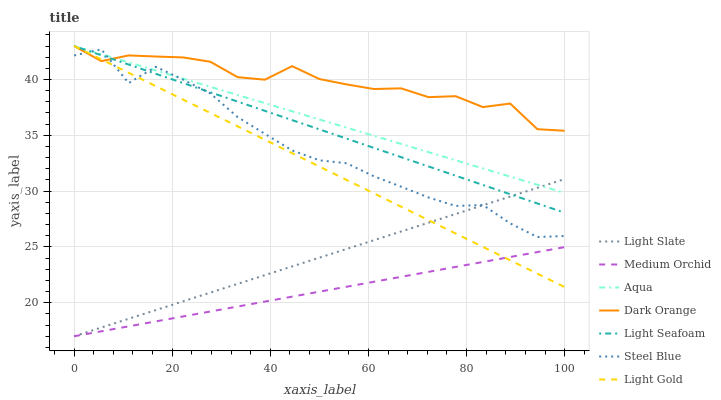Does Light Slate have the minimum area under the curve?
Answer yes or no. No. Does Light Slate have the maximum area under the curve?
Answer yes or no. No. Is Medium Orchid the smoothest?
Answer yes or no. No. Is Medium Orchid the roughest?
Answer yes or no. No. Does Aqua have the lowest value?
Answer yes or no. No. Does Light Slate have the highest value?
Answer yes or no. No. Is Medium Orchid less than Light Seafoam?
Answer yes or no. Yes. Is Steel Blue greater than Medium Orchid?
Answer yes or no. Yes. Does Medium Orchid intersect Light Seafoam?
Answer yes or no. No. 